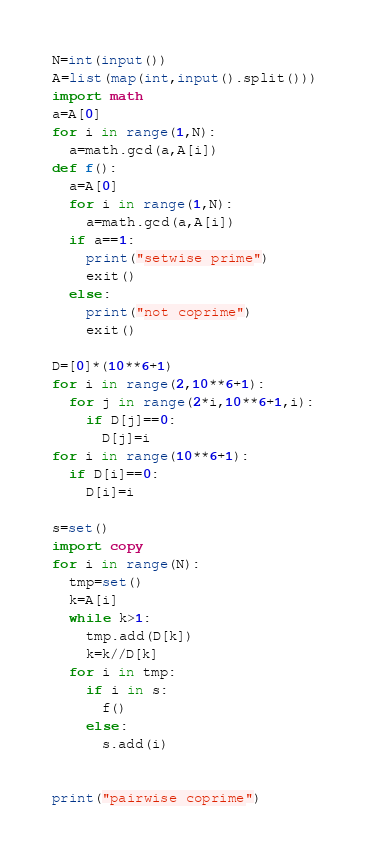<code> <loc_0><loc_0><loc_500><loc_500><_Python_>N=int(input())
A=list(map(int,input().split()))
import math
a=A[0]
for i in range(1,N):
  a=math.gcd(a,A[i])
def f():
  a=A[0]
  for i in range(1,N):
    a=math.gcd(a,A[i])
  if a==1:
    print("setwise prime")
    exit()
  else:
    print("not coprime")
    exit()
  
D=[0]*(10**6+1)
for i in range(2,10**6+1):
  for j in range(2*i,10**6+1,i):
    if D[j]==0:
      D[j]=i
for i in range(10**6+1):
  if D[i]==0:
    D[i]=i

s=set()
import copy
for i in range(N):
  tmp=set()
  k=A[i]
  while k>1:
    tmp.add(D[k])
    k=k//D[k]
  for i in tmp:
    if i in s:
      f()
    else:
      s.add(i)


print("pairwise coprime")</code> 